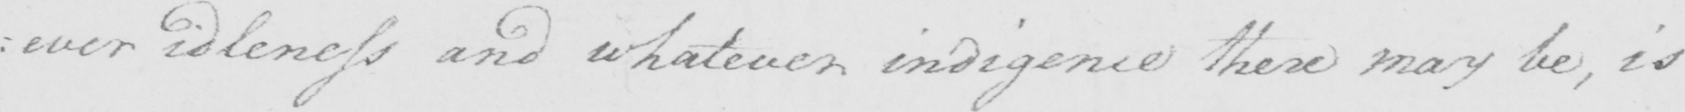What does this handwritten line say? : ever idleness and whatever indigence there may be , is 